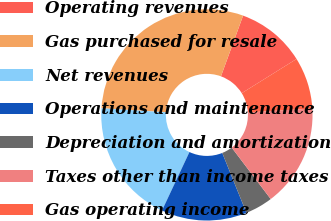Convert chart. <chart><loc_0><loc_0><loc_500><loc_500><pie_chart><fcel>Operating revenues<fcel>Gas purchased for resale<fcel>Net revenues<fcel>Operations and maintenance<fcel>Depreciation and amortization<fcel>Taxes other than income taxes<fcel>Gas operating income<nl><fcel>10.56%<fcel>29.57%<fcel>19.01%<fcel>13.09%<fcel>4.22%<fcel>15.63%<fcel>7.92%<nl></chart> 